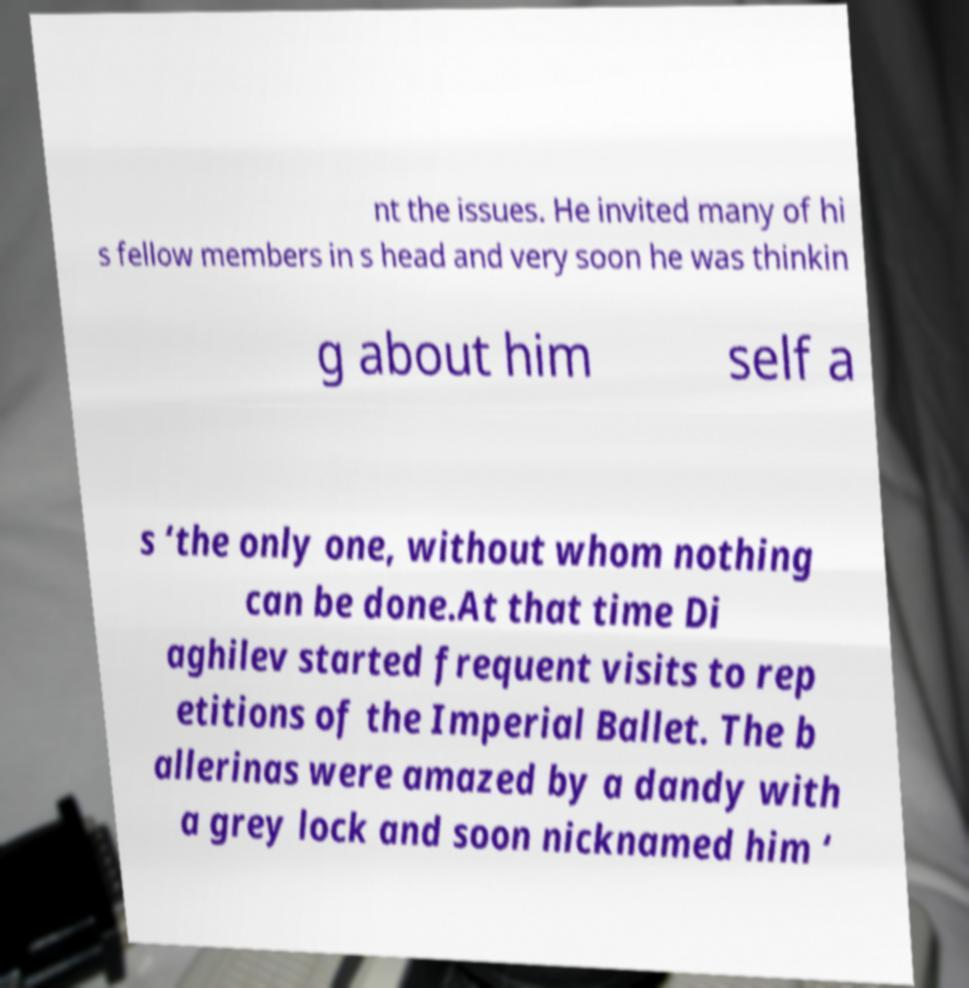What messages or text are displayed in this image? I need them in a readable, typed format. nt the issues. He invited many of hi s fellow members in s head and very soon he was thinkin g about him self a s ‘the only one, without whom nothing can be done.At that time Di aghilev started frequent visits to rep etitions of the Imperial Ballet. The b allerinas were amazed by a dandy with a grey lock and soon nicknamed him ‘ 